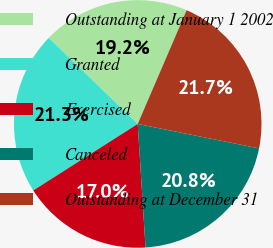<chart> <loc_0><loc_0><loc_500><loc_500><pie_chart><fcel>Outstanding at January 1 2002<fcel>Granted<fcel>Exercised<fcel>Canceled<fcel>Outstanding at December 31<nl><fcel>19.23%<fcel>21.26%<fcel>16.98%<fcel>20.83%<fcel>21.7%<nl></chart> 